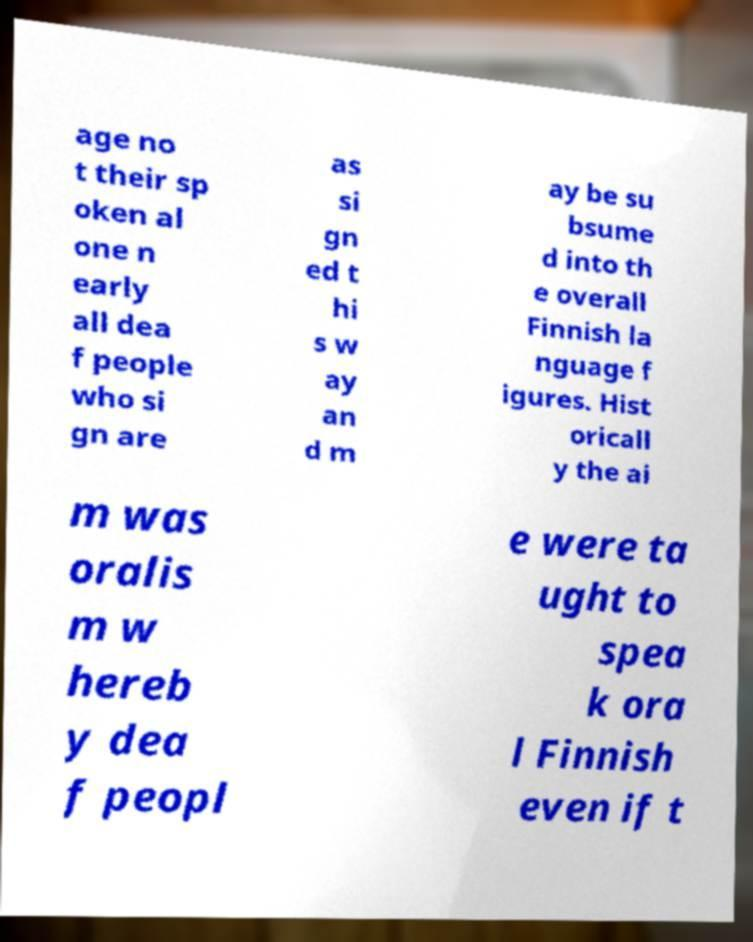Please identify and transcribe the text found in this image. age no t their sp oken al one n early all dea f people who si gn are as si gn ed t hi s w ay an d m ay be su bsume d into th e overall Finnish la nguage f igures. Hist oricall y the ai m was oralis m w hereb y dea f peopl e were ta ught to spea k ora l Finnish even if t 